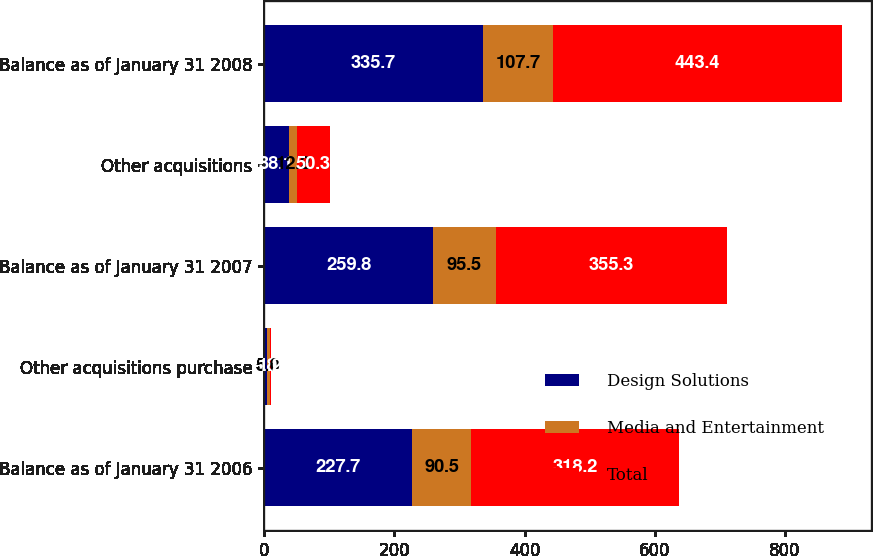Convert chart. <chart><loc_0><loc_0><loc_500><loc_500><stacked_bar_chart><ecel><fcel>Balance as of January 31 2006<fcel>Other acquisitions purchase<fcel>Balance as of January 31 2007<fcel>Other acquisitions<fcel>Balance as of January 31 2008<nl><fcel>Design Solutions<fcel>227.7<fcel>3.8<fcel>259.8<fcel>38.1<fcel>335.7<nl><fcel>Media and Entertainment<fcel>90.5<fcel>5<fcel>95.5<fcel>12.2<fcel>107.7<nl><fcel>Total<fcel>318.2<fcel>1.2<fcel>355.3<fcel>50.3<fcel>443.4<nl></chart> 